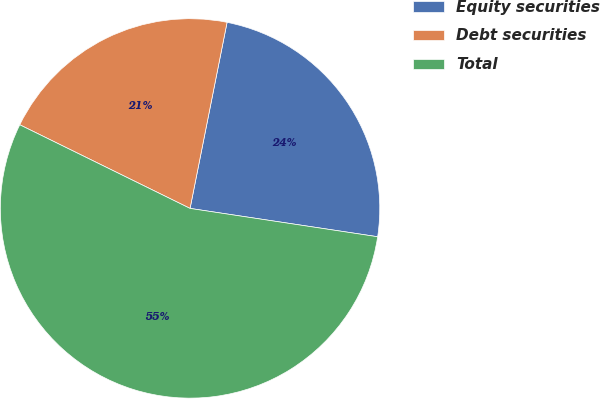Convert chart. <chart><loc_0><loc_0><loc_500><loc_500><pie_chart><fcel>Equity securities<fcel>Debt securities<fcel>Total<nl><fcel>24.26%<fcel>20.86%<fcel>54.88%<nl></chart> 